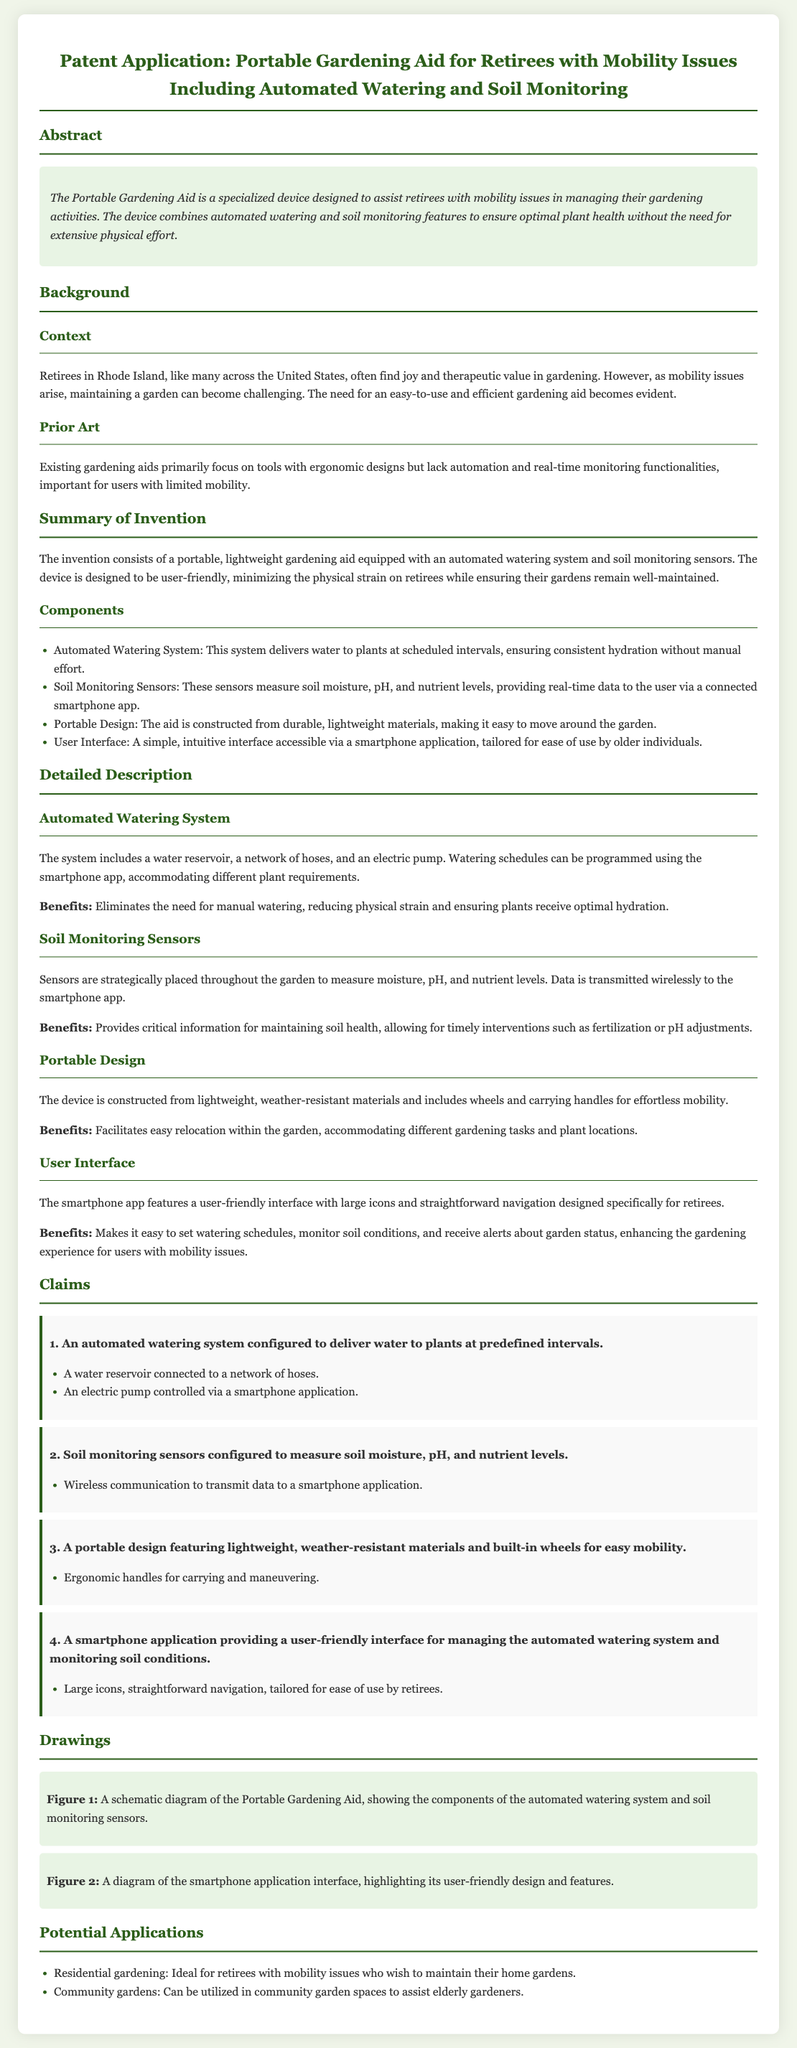What is the main purpose of the Portable Gardening Aid? The main purpose is to assist retirees with mobility issues in managing their gardening activities.
Answer: assist retirees with mobility issues What features does the Automated Watering System include? The Automated Watering System includes a water reservoir, a network of hoses, and an electric pump.
Answer: water reservoir, network of hoses, electric pump What does the soil monitoring sensors measure? The soil monitoring sensors measure soil moisture, pH, and nutrient levels.
Answer: soil moisture, pH, nutrient levels How are the data from the soil monitoring sensors communicated? The data is communicated wirelessly to the smartphone app.
Answer: wirelessly to the smartphone app What is the benefit of the portable design? The portable design facilitates easy relocation within the garden.
Answer: easy relocation within the garden What size icons does the smartphone application feature? The smartphone application features large icons.
Answer: large icons What type of materials is the device constructed from? The device is constructed from lightweight, weather-resistant materials.
Answer: lightweight, weather-resistant materials How many claims are presented in the patent application? There are four claims presented in the patent application.
Answer: four claims What is highlighted in Figure 2? Figure 2 highlights the smartphone application interface design and features.
Answer: smartphone application interface design and features 